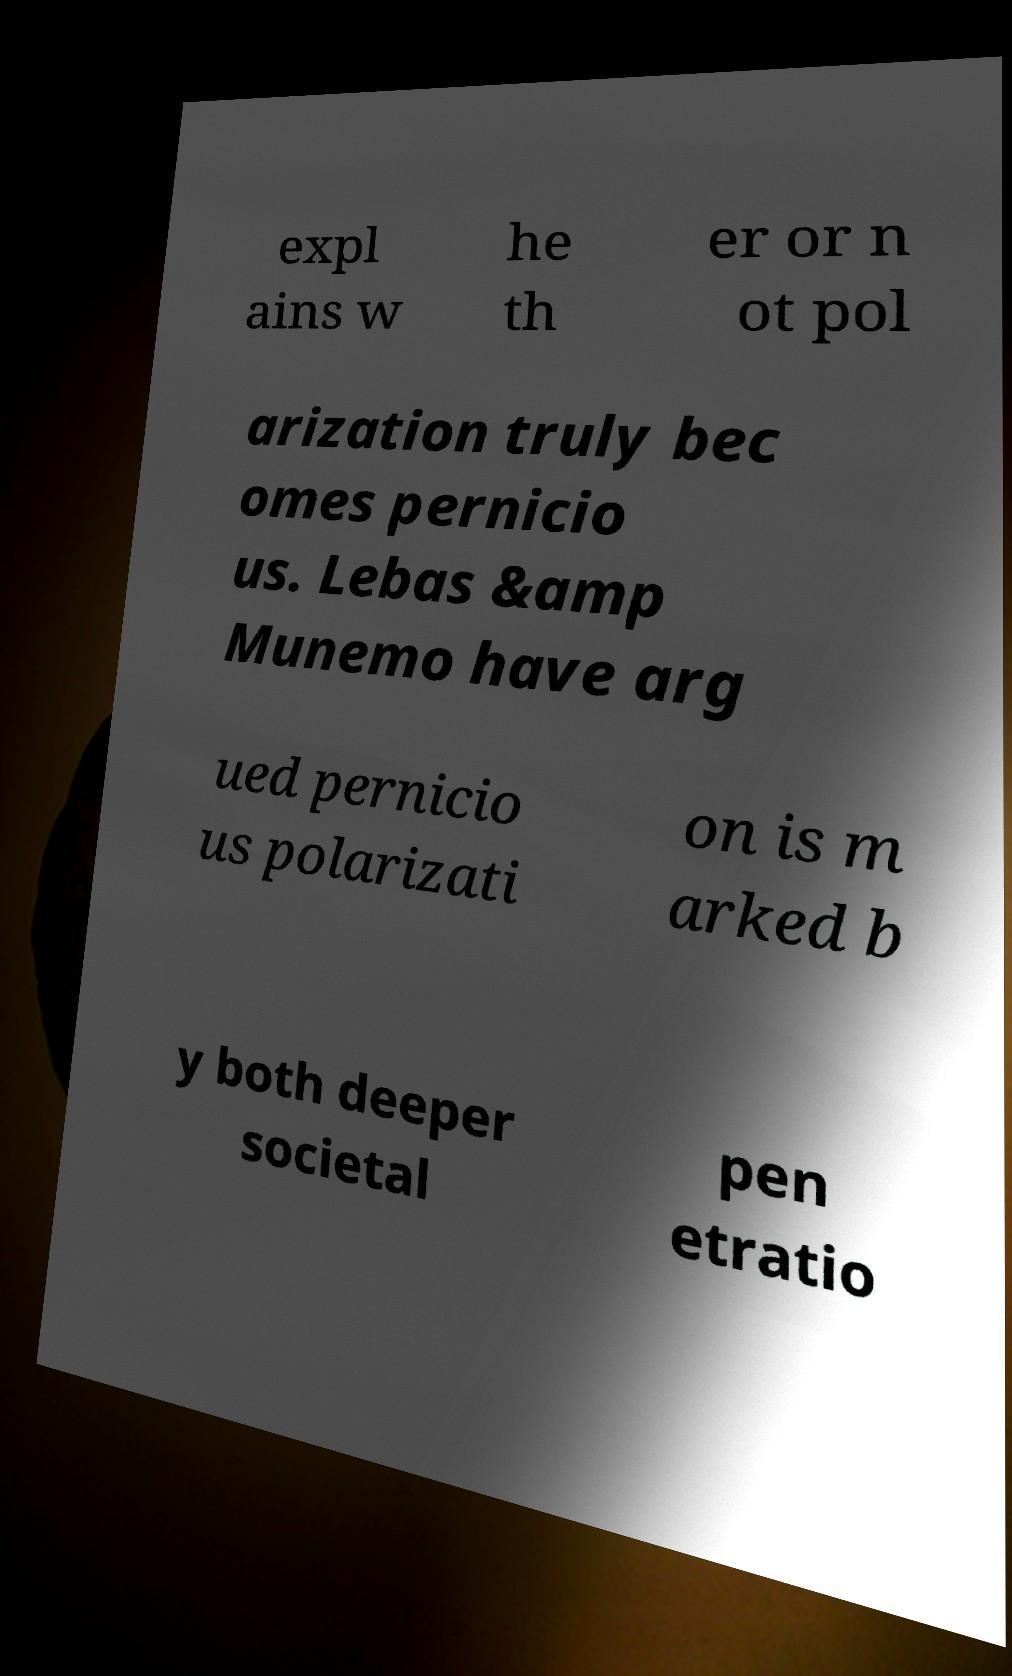Can you accurately transcribe the text from the provided image for me? expl ains w he th er or n ot pol arization truly bec omes pernicio us. Lebas &amp Munemo have arg ued pernicio us polarizati on is m arked b y both deeper societal pen etratio 